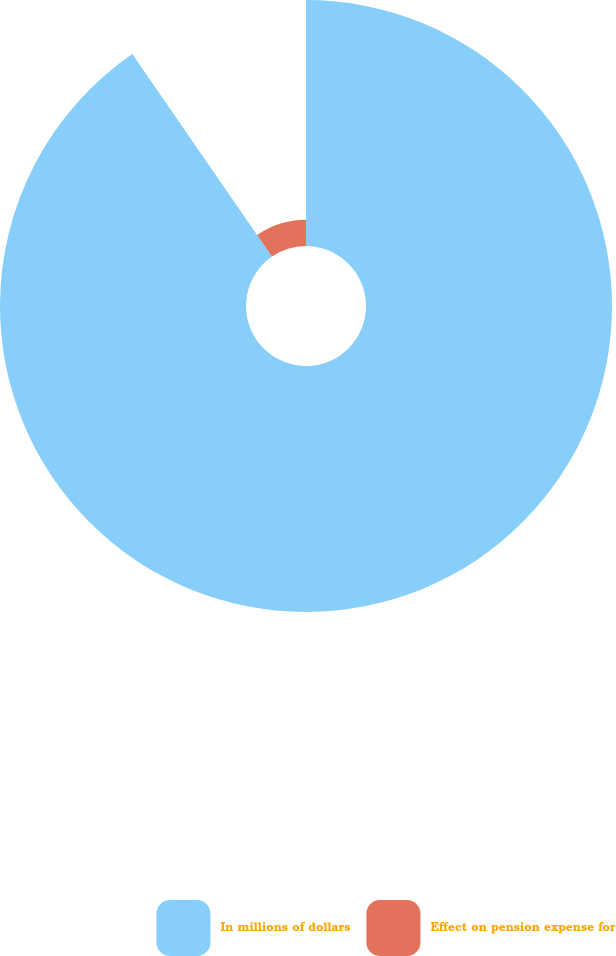<chart> <loc_0><loc_0><loc_500><loc_500><pie_chart><fcel>In millions of dollars<fcel>Effect on pension expense for<nl><fcel>90.39%<fcel>9.61%<nl></chart> 